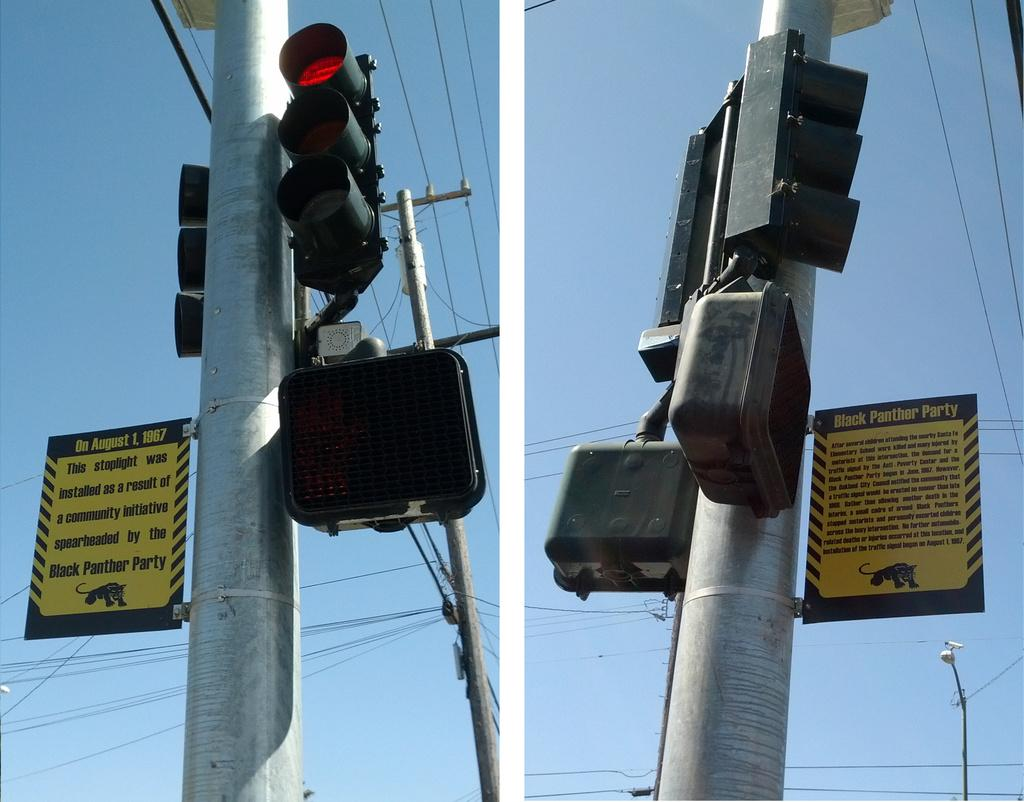<image>
Provide a brief description of the given image. The stop lights have signs attached to them that give a little bit of history of the Black Panther Party. 